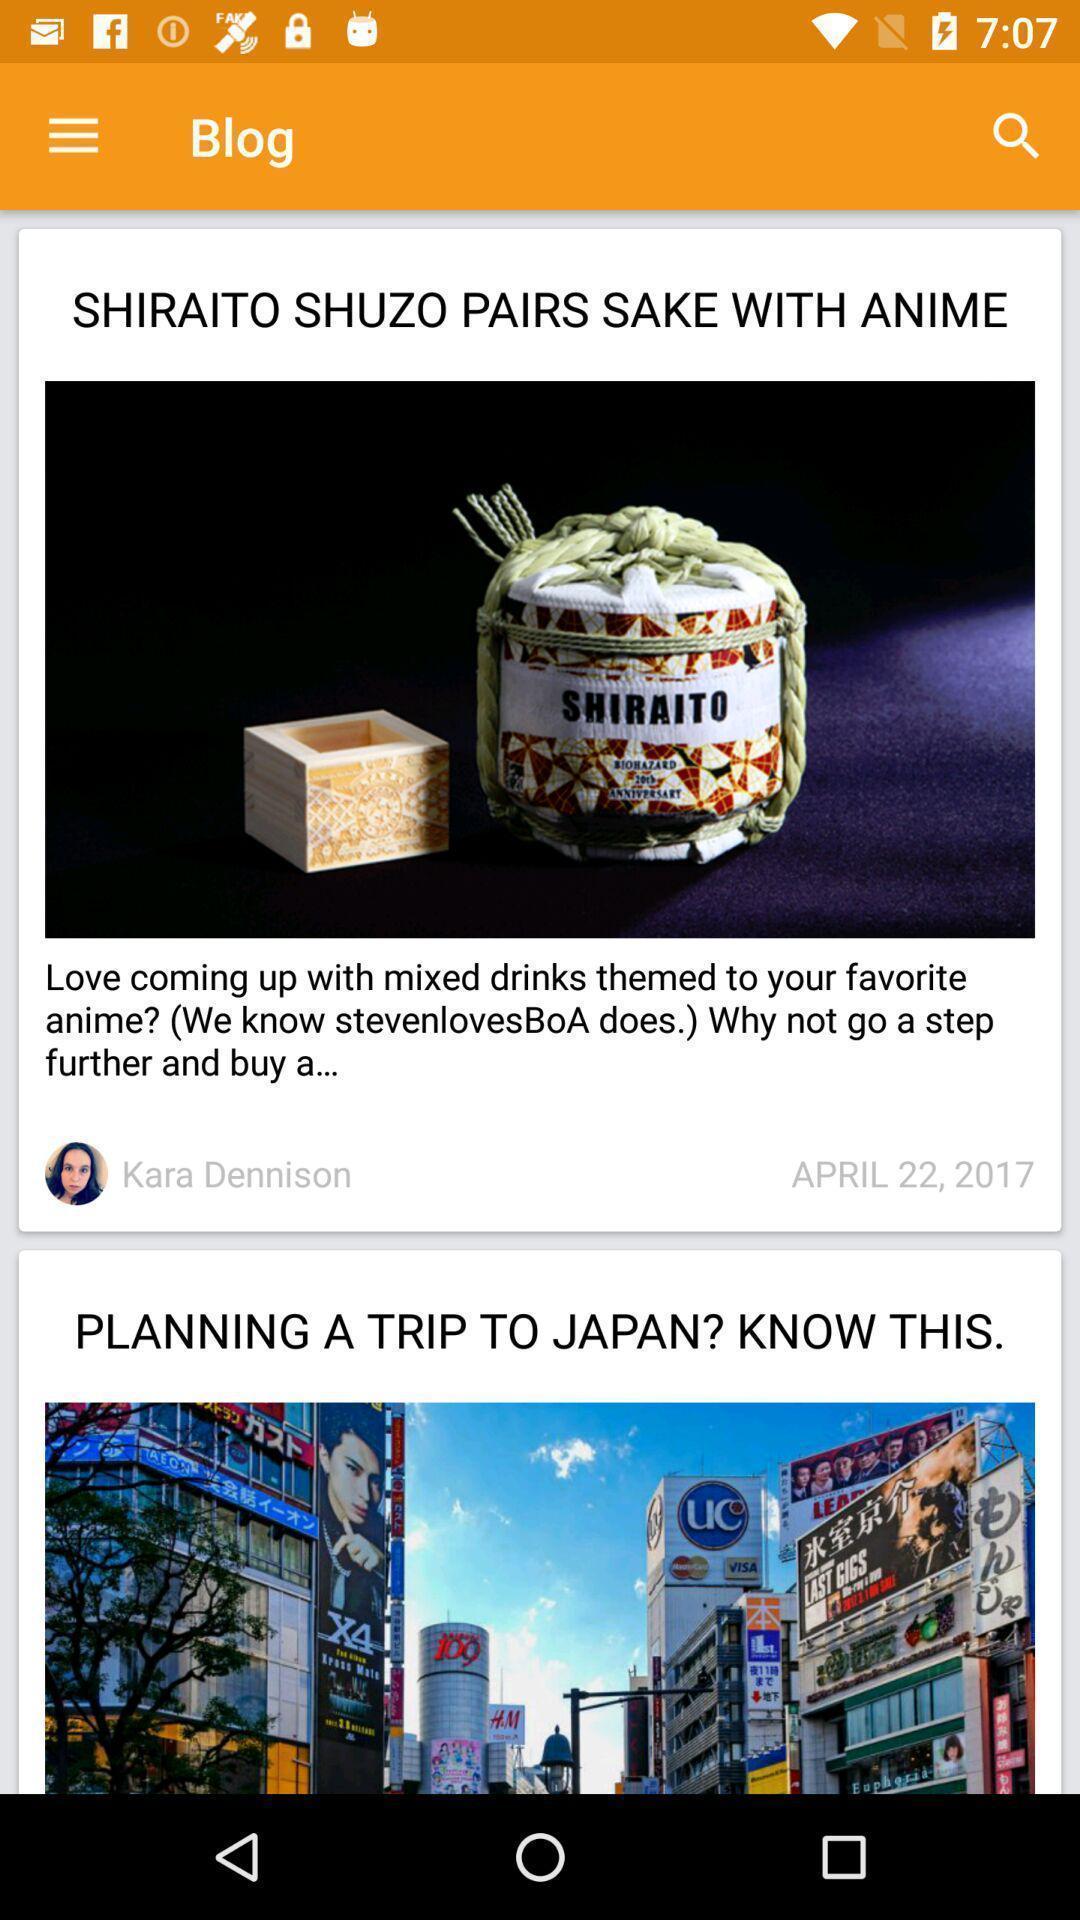What details can you identify in this image? Various articles displayed of a news app. 